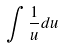<formula> <loc_0><loc_0><loc_500><loc_500>\int \frac { 1 } { u } d u</formula> 